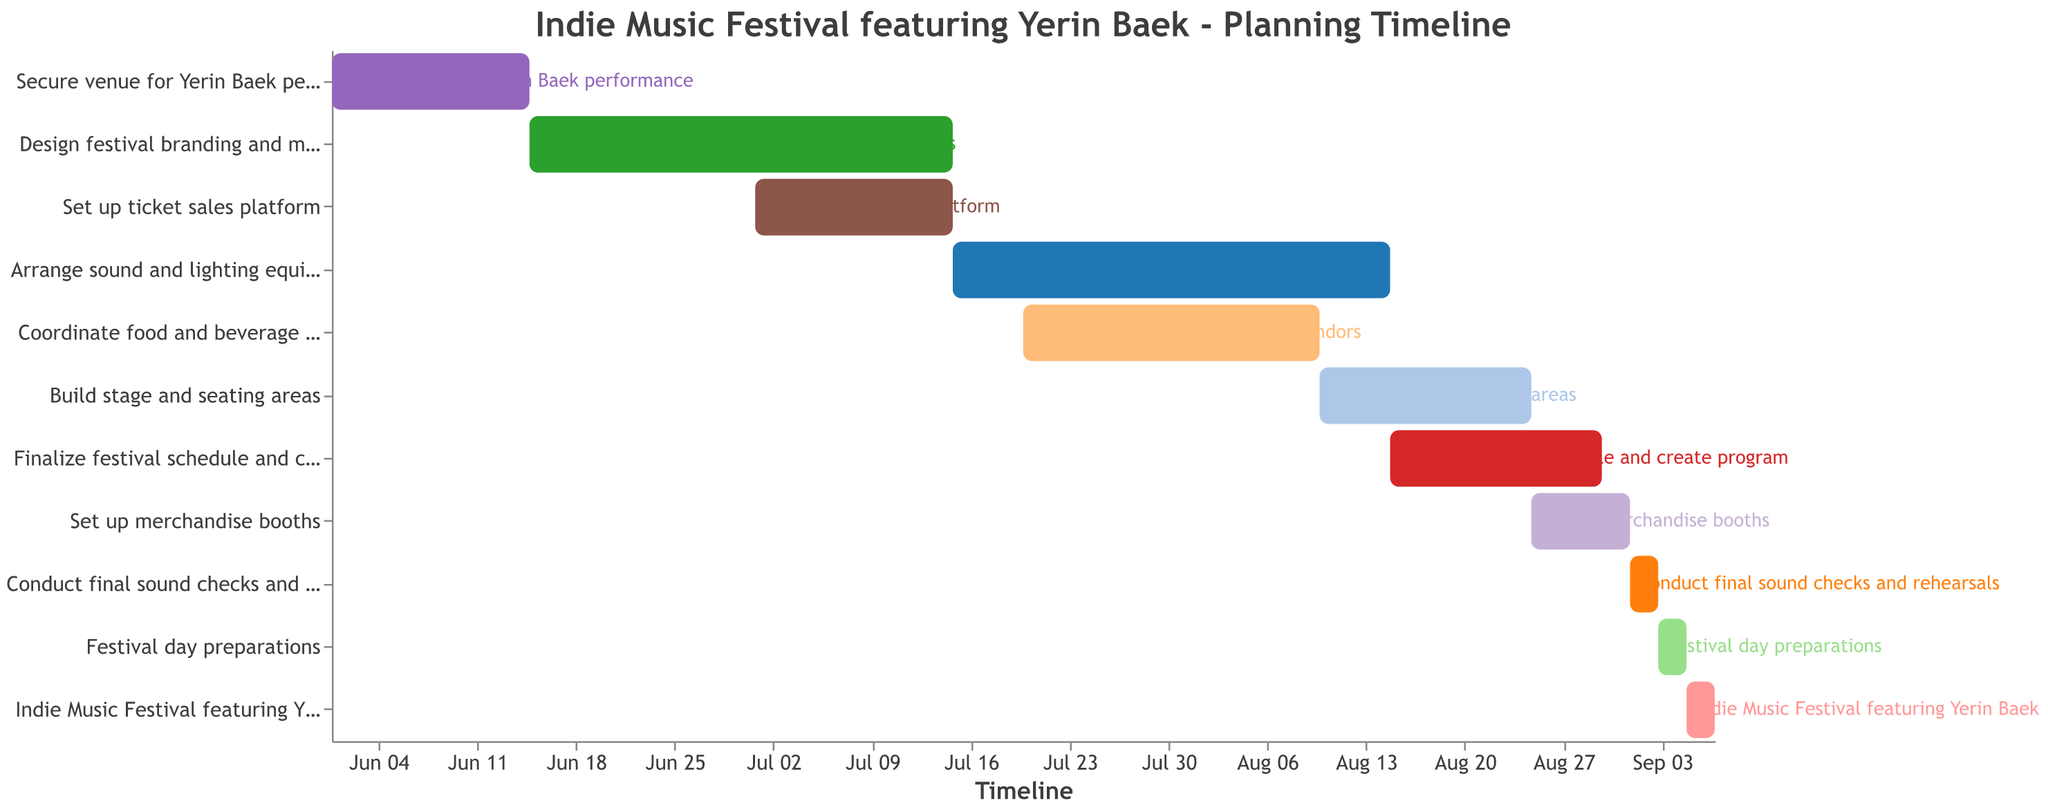When does the task 'Set up ticket sales platform' start and end? The task 'Set up ticket sales platform' starts at the beginning of July and ends by mid-July.
Answer: July 1 to July 15 Which task has the longest duration and how long is it? The task 'Arrange sound and lighting equipment' spans from mid-July to mid-August, lasting for an entire month.
Answer: Arrange sound and lighting equipment, 1 month What's the next step after 'Build stage and seating areas'? Following 'Build stage and seating areas,' the next task is to 'Finalize festival schedule and create program.' This task starts mid-August and ends at the end of August.
Answer: Finalize festival schedule and create program How many days are allocated for the actual Indie Music Festival featuring Yerin Baek? The Indie Music Festival featuring Yerin Baek takes place over three days, from September 5 to September 7.
Answer: 3 days Which two tasks overlap the most in their scheduling? The tasks 'Arrange sound and lighting equipment' and 'Coordinate food and beverage vendors' have the most overlap, both tasks occurring during almost the same period between July and August.
Answer: Arrange sound and lighting equipment and Coordinate food and beverage vendors What's the total duration of tasks starting in July? Tasks starting in July are 'Set up ticket sales platform,' 'Arrange sound and lighting equipment,' and 'Coordinate food and beverage vendors.' Summing their durations: 'Set up ticket sales platform' (15 days), 'Arrange sound and lighting equipment' (1 month), and 'Coordinate food and beverage vendors' (21 days), gives a rough total of approximately 2 months.
Answer: Approximately 2 months Between which dates is the task 'Festival day preparations' scheduled? 'Festival day preparations' are scheduled to take place from September 3 to September 5, just before the Indie Music Festival.
Answer: September 3 to September 5 Which task finishes right on the day the Indie Music Festival starts? 'Festival day preparations' finishes on September 5, which is the same day the Indie Music Festival starts.
Answer: Festival day preparations What is the last task to be completed before the festival itself begins? The last task before the festival is 'Festival day preparations,' which ends on the first day of the festival, September 5.
Answer: Festival day preparations 